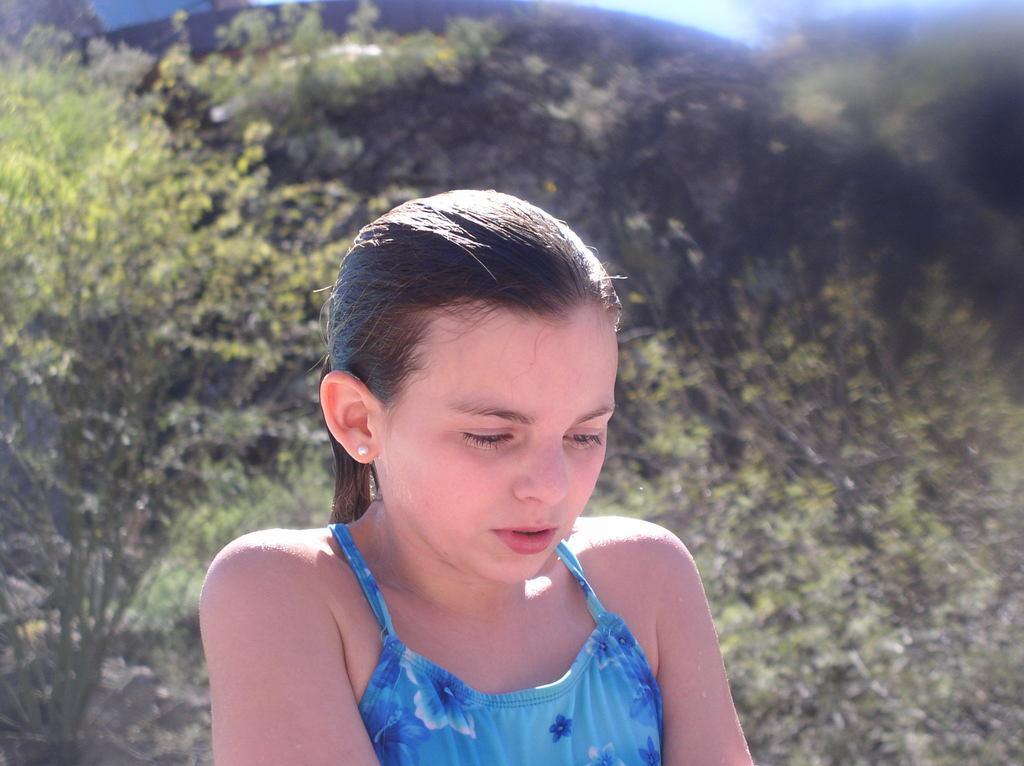Could you give a brief overview of what you see in this image? In this image there is a girl she is wearing blue dress, in the background there are plants. 